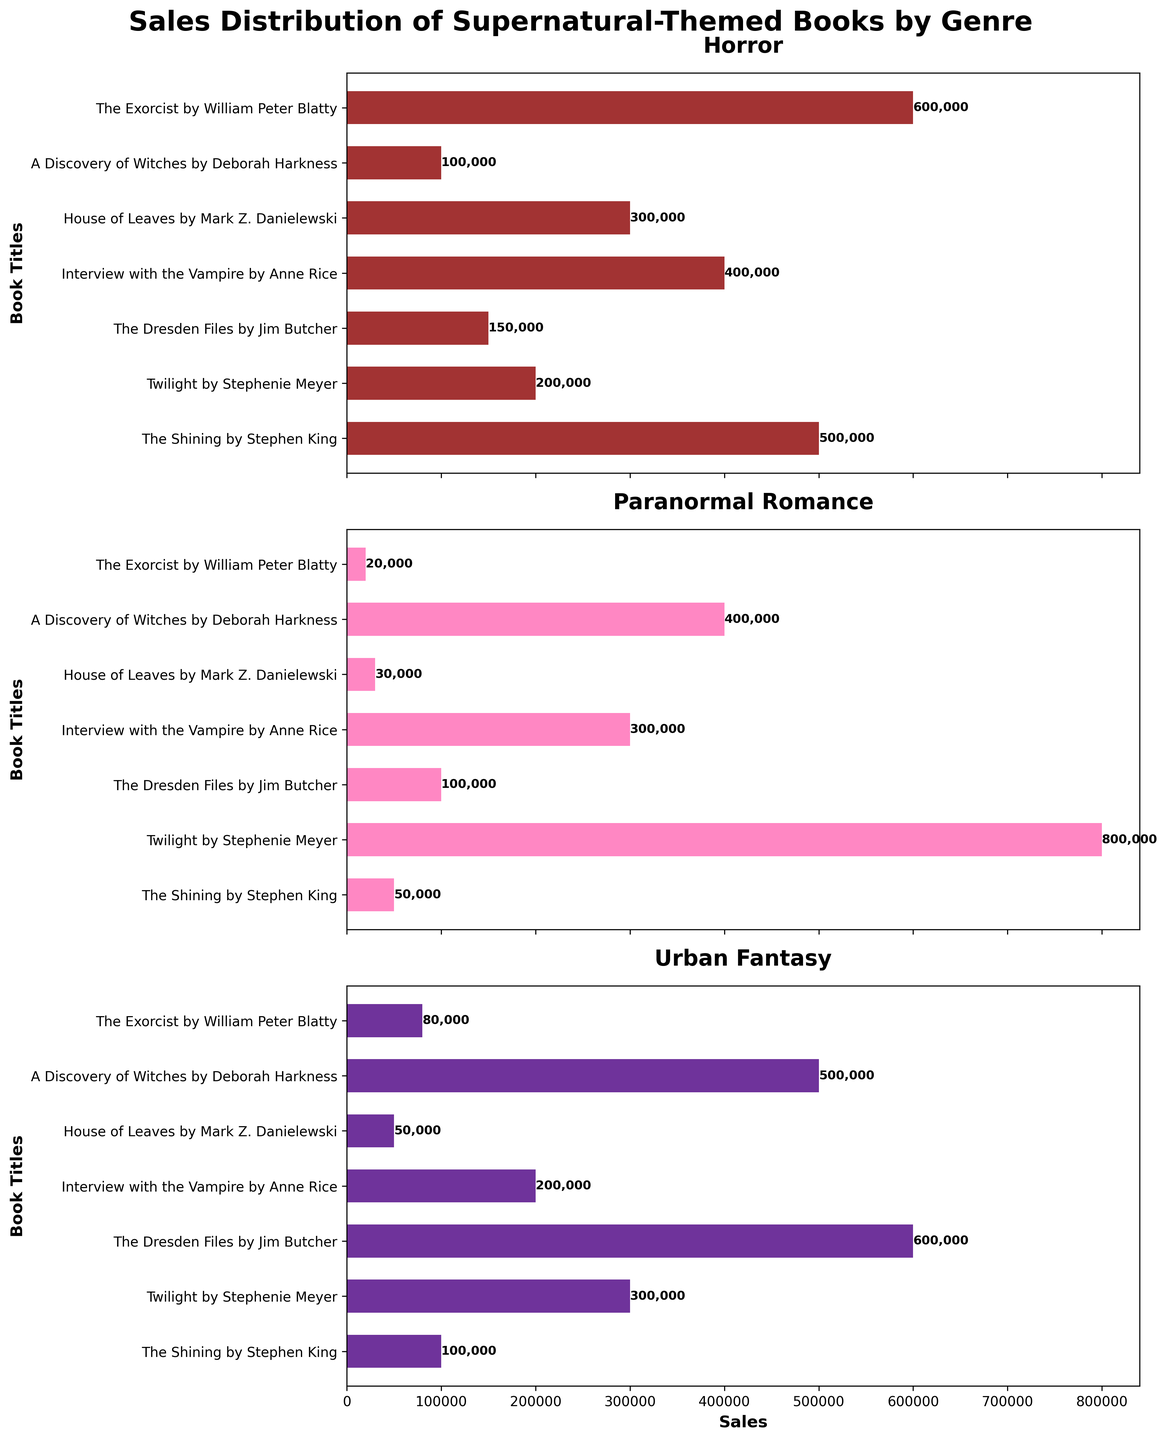Which genre has the highest overall book sales? By adding the sales figures for each book in each genre, we find: Horror (500,000 + 200,000 + 150,000 + 400,000 + 300,000 + 100,000 + 600,000) = 2,250,000, Paranormal Romance (50,000 + 800,000 + 100,000 + 300,000 + 30,000 + 400,000 + 20,000) = 1,700,000, Urban Fantasy (100,000 + 300,000 + 600,000 + 200,000 + 50,000 + 500,000 + 80,000) = 1,830,000. Thus, Horror is the genre with the highest overall book sales.
Answer: Horror Which book has the highest sales in the Paranormal Romance genre? Refer to the subplot for Paranormal Romance, "Twilight" by Stephenie Meyer has the highest sales with 800,000 units.
Answer: "Twilight" by Stephenie Meyer How do the sales of "The Shining" compare across all three genres? In the Horror genre, "The Shining" has 500,000 sales, in Paranormal Romance it has 50,000, and in Urban Fantasy, it has 100,000.
Answer: Horror: 500,000, Paranormal Romance: 50,000, Urban Fantasy: 100,000 What is the total sales figure for "Interview with the Vampire"? Summing up the sales across genres: Horror (400,000) + Paranormal Romance (300,000) + Urban Fantasy (200,000) = 900,000.
Answer: 900,000 Which genre has the least variation in book sales? By visually inspecting the range of sales values on each subplot: Paranormal Romance appears to have the least variation, as most sales hover around the mid to high range.
Answer: Paranormal Romance In which genre did "House of Leaves" perform the weakest? Referring to individual subplots, "House of Leaves" has the lowest sales in the Paranormal Romance genre with 30,000 units.
Answer: Paranormal Romance Compare the sales of "The Exorcist" to "A Discovery of Witches" in the Urban Fantasy genre. "The Exorcist" sales in Urban Fantasy are 80,000 while "A Discovery of Witches" has 500,000.
Answer: "A Discovery of Witches" has higher sales Which book has the most consistent sales across all genres? By observing sales figures for each book in all genres, "Interview with the Vampire" is relatively consistent: Horror (400,000), Paranormal Romance (300,000), Urban Fantasy (200,000).
Answer: "Interview with the Vampire" What is the difference in sales between "Twilight" and "The Dresden Files" in the Paranormal Romance genre? Subtracting the sales of "The Dresden Files" from "Twilight": 800,000 - 100,000 = 700,000.
Answer: 700,000 How do the total sales of the highest and lowest-selling books compare in the Horror genre? The highest-selling book in Horror is "The Exorcist" with 600,000 sales, and the lowest is "A Discovery of Witches" with 100,000 sales. The difference is 600,000 - 100,000 = 500,000.
Answer: 500,000 